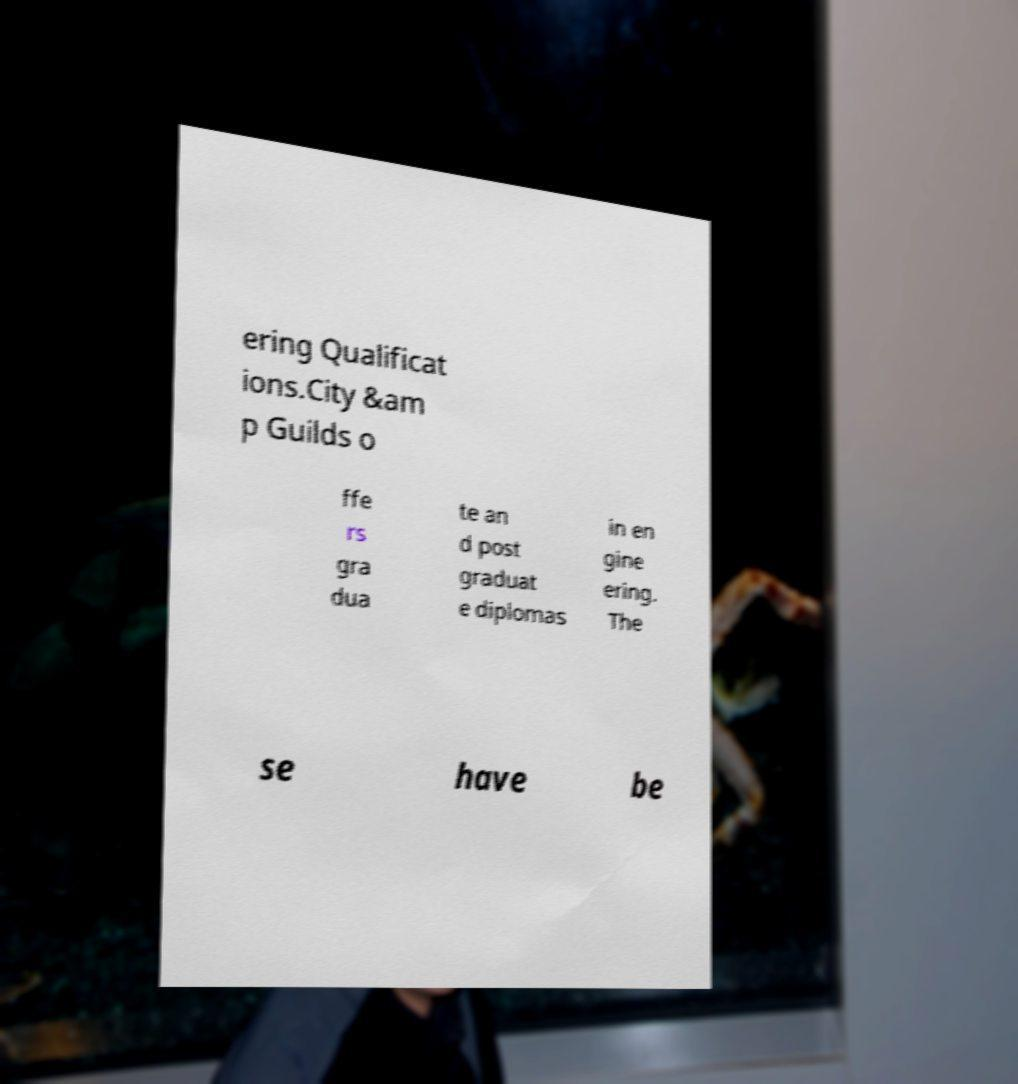Could you assist in decoding the text presented in this image and type it out clearly? ering Qualificat ions.City &am p Guilds o ffe rs gra dua te an d post graduat e diplomas in en gine ering. The se have be 